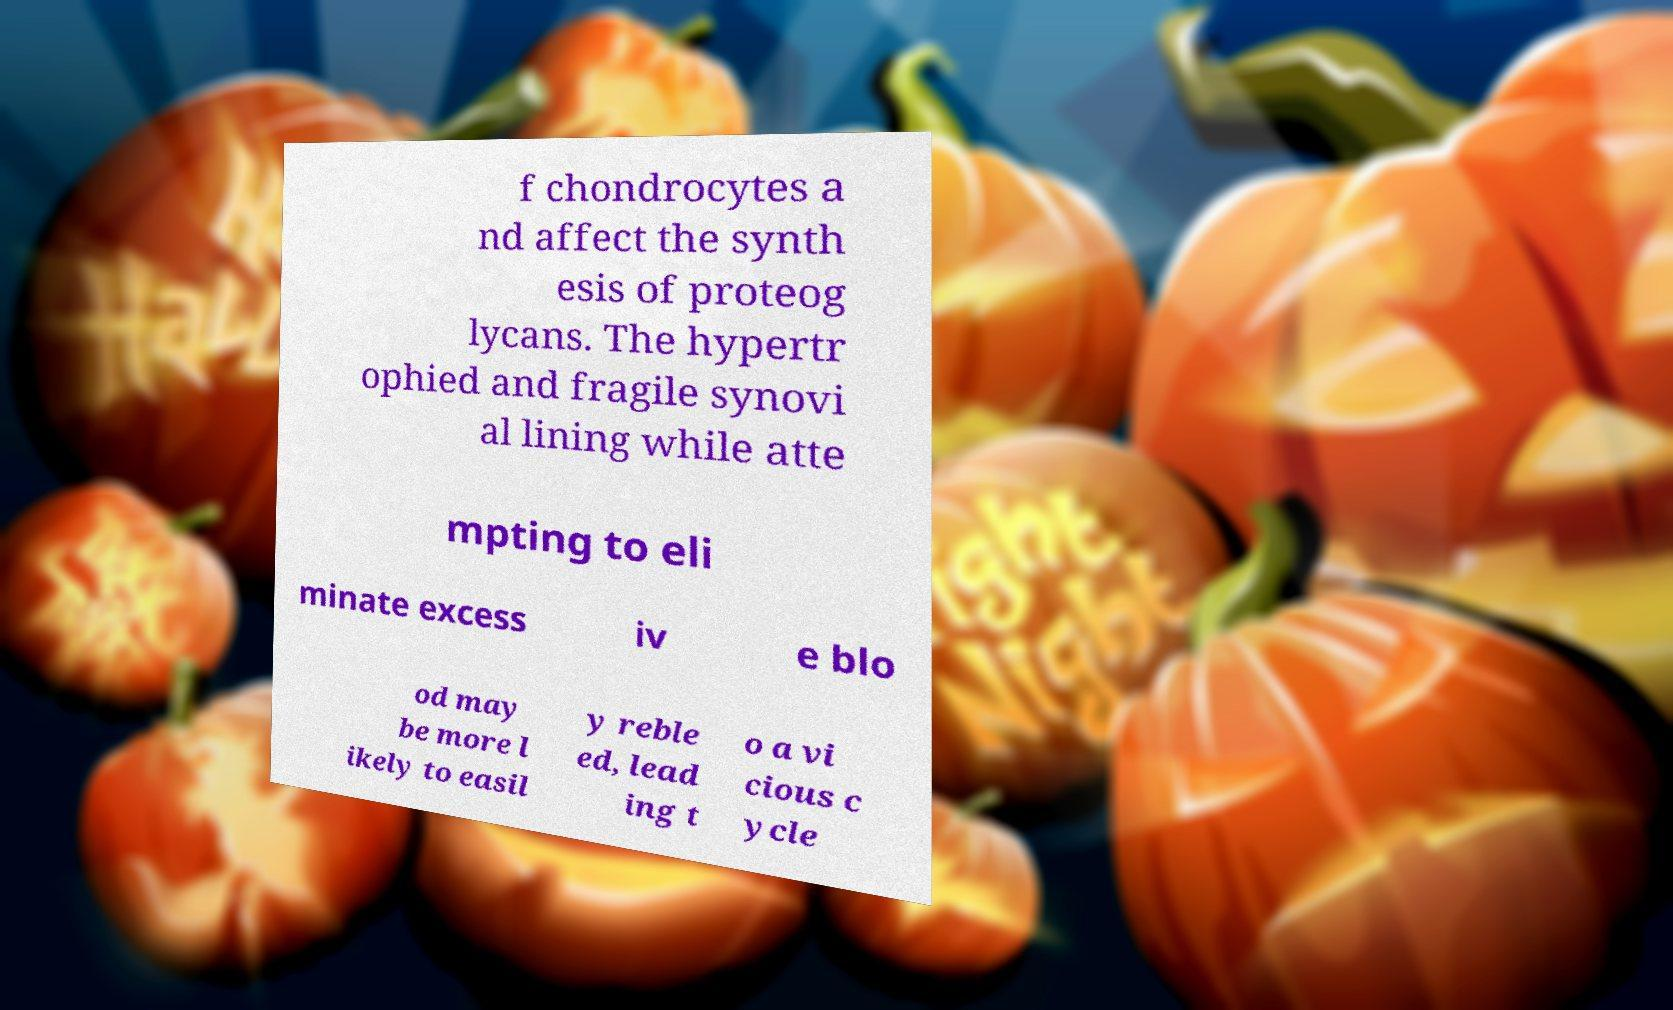I need the written content from this picture converted into text. Can you do that? f chondrocytes a nd affect the synth esis of proteog lycans. The hypertr ophied and fragile synovi al lining while atte mpting to eli minate excess iv e blo od may be more l ikely to easil y reble ed, lead ing t o a vi cious c ycle 